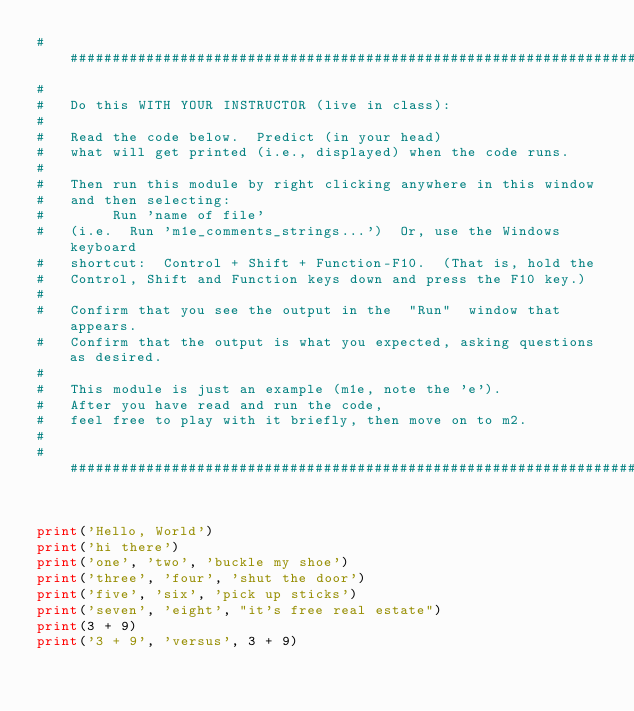<code> <loc_0><loc_0><loc_500><loc_500><_Python_>###############################################################################
#
#   Do this WITH YOUR INSTRUCTOR (live in class):
#
#   Read the code below.  Predict (in your head)
#   what will get printed (i.e., displayed) when the code runs.
#
#   Then run this module by right clicking anywhere in this window
#   and then selecting:
#        Run 'name of file'
#   (i.e.  Run 'm1e_comments_strings...')  Or, use the Windows keyboard
#   shortcut:  Control + Shift + Function-F10.  (That is, hold the
#   Control, Shift and Function keys down and press the F10 key.)
#
#   Confirm that you see the output in the  "Run"  window that appears.
#   Confirm that the output is what you expected, asking questions as desired.
#
#   This module is just an example (m1e, note the 'e').
#   After you have read and run the code,
#   feel free to play with it briefly, then move on to m2.
#
###############################################################################


print('Hello, World')
print('hi there')
print('one', 'two', 'buckle my shoe')
print('three', 'four', 'shut the door')
print('five', 'six', 'pick up sticks')
print('seven', 'eight', "it's free real estate")
print(3 + 9)
print('3 + 9', 'versus', 3 + 9)
</code> 